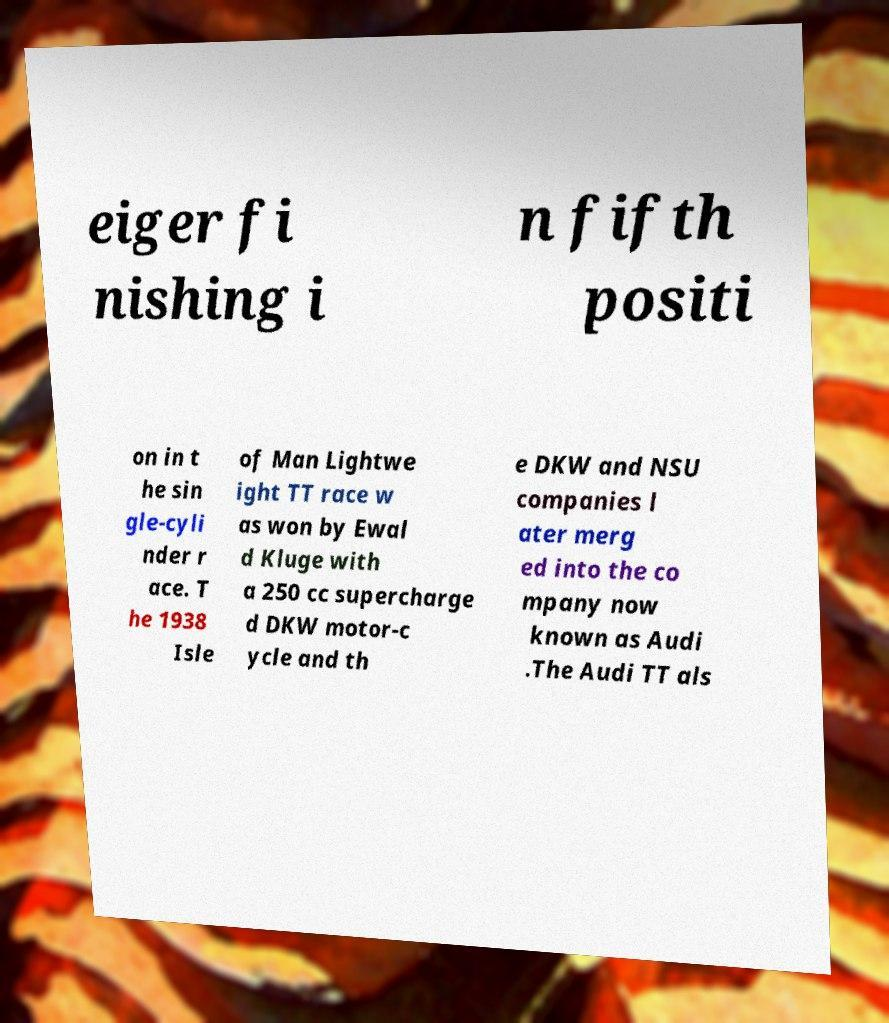What messages or text are displayed in this image? I need them in a readable, typed format. eiger fi nishing i n fifth positi on in t he sin gle-cyli nder r ace. T he 1938 Isle of Man Lightwe ight TT race w as won by Ewal d Kluge with a 250 cc supercharge d DKW motor-c ycle and th e DKW and NSU companies l ater merg ed into the co mpany now known as Audi .The Audi TT als 